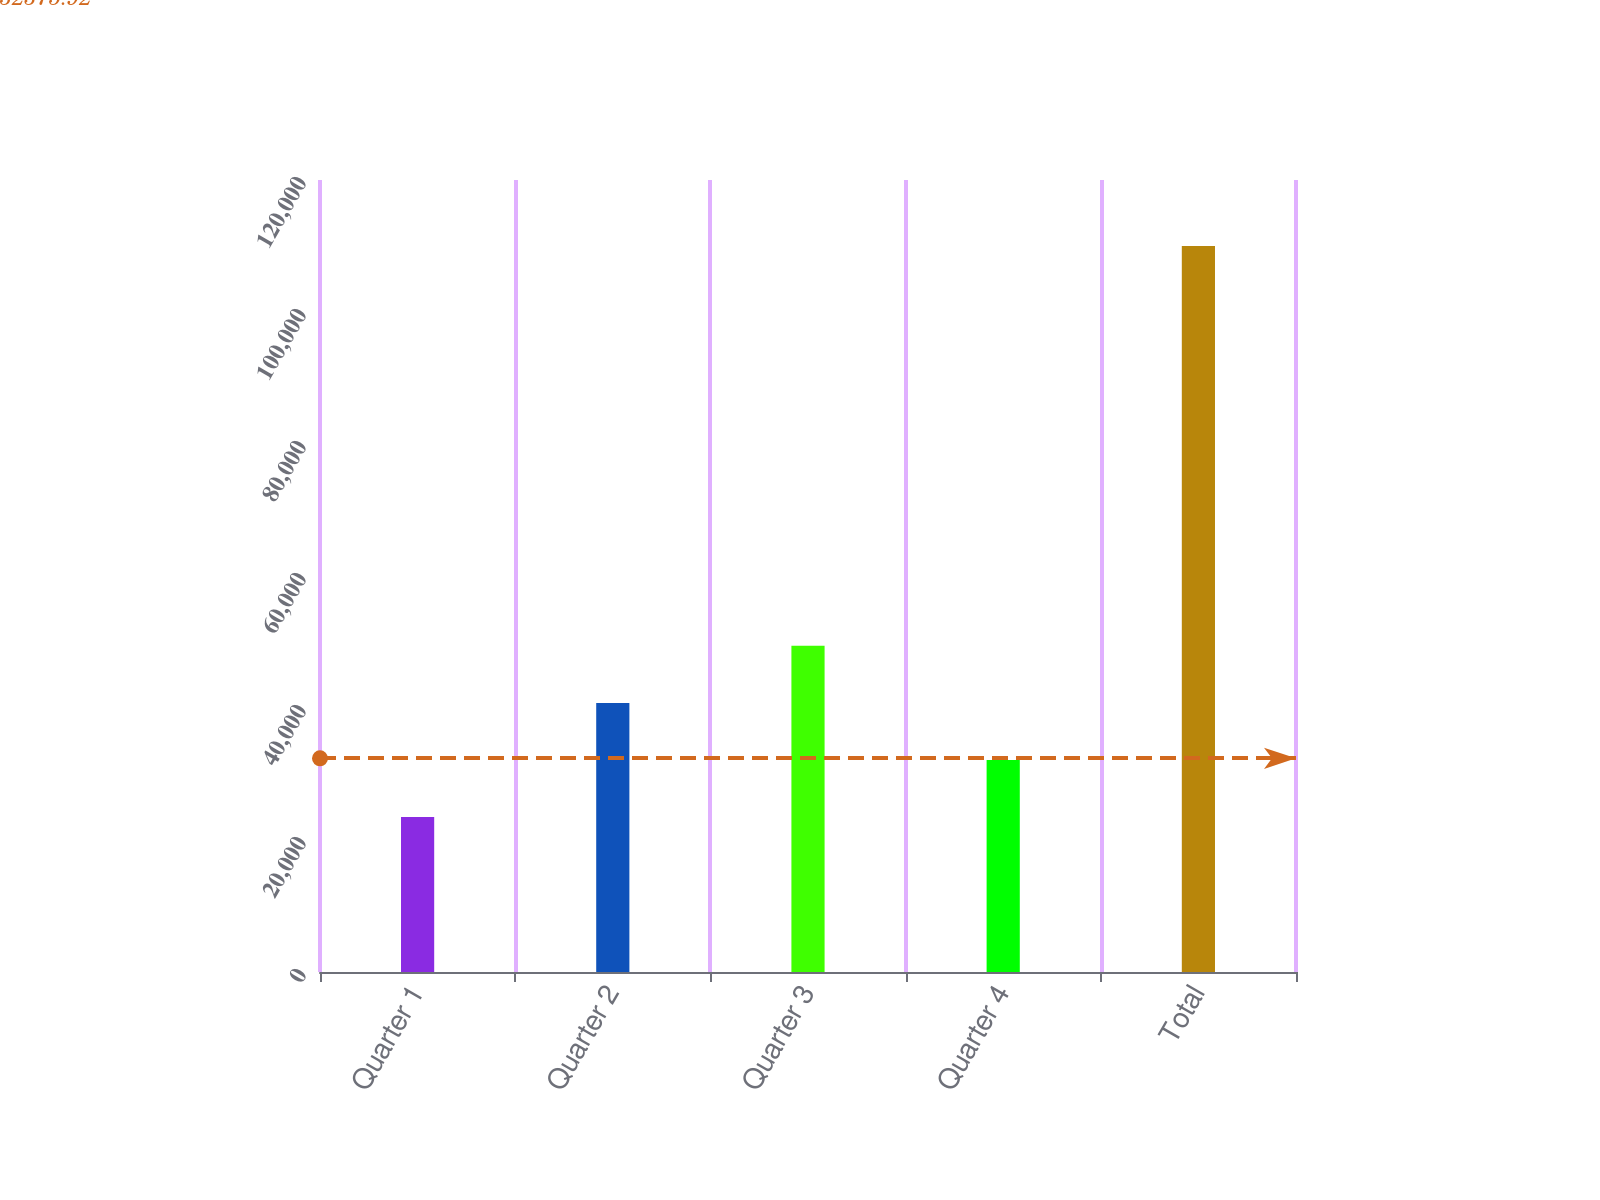<chart> <loc_0><loc_0><loc_500><loc_500><bar_chart><fcel>Quarter 1<fcel>Quarter 2<fcel>Quarter 3<fcel>Quarter 4<fcel>Total<nl><fcel>23468<fcel>40771.4<fcel>49423.1<fcel>32119.7<fcel>109985<nl></chart> 